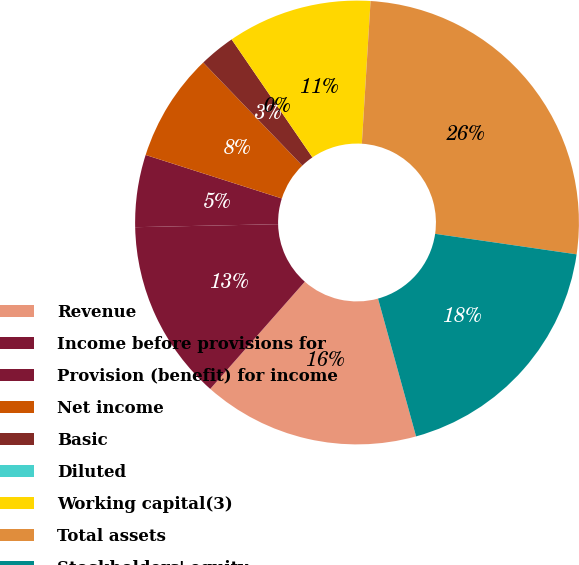Convert chart to OTSL. <chart><loc_0><loc_0><loc_500><loc_500><pie_chart><fcel>Revenue<fcel>Income before provisions for<fcel>Provision (benefit) for income<fcel>Net income<fcel>Basic<fcel>Diluted<fcel>Working capital(3)<fcel>Total assets<fcel>Stockholders' equity<nl><fcel>15.79%<fcel>13.16%<fcel>5.26%<fcel>7.89%<fcel>2.63%<fcel>0.0%<fcel>10.53%<fcel>26.32%<fcel>18.42%<nl></chart> 